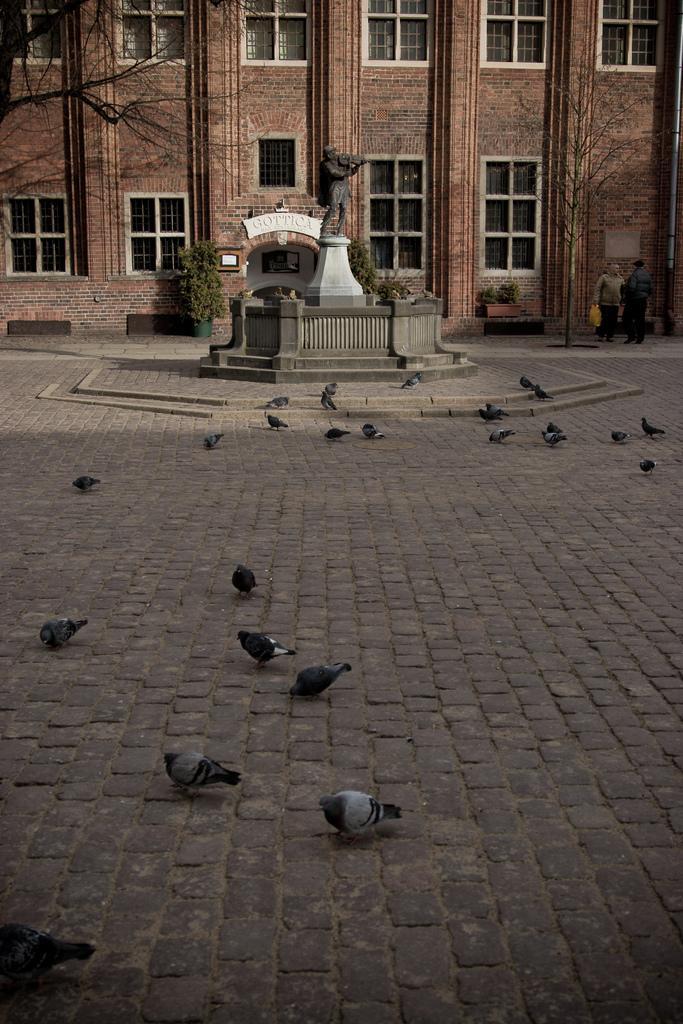Could you give a brief overview of what you see in this image? In this image there are so many pigeons eating the grains which are on the floor. In the middle there is a statue. In the background there is a building with the windows. On the left side top there is a tree. 